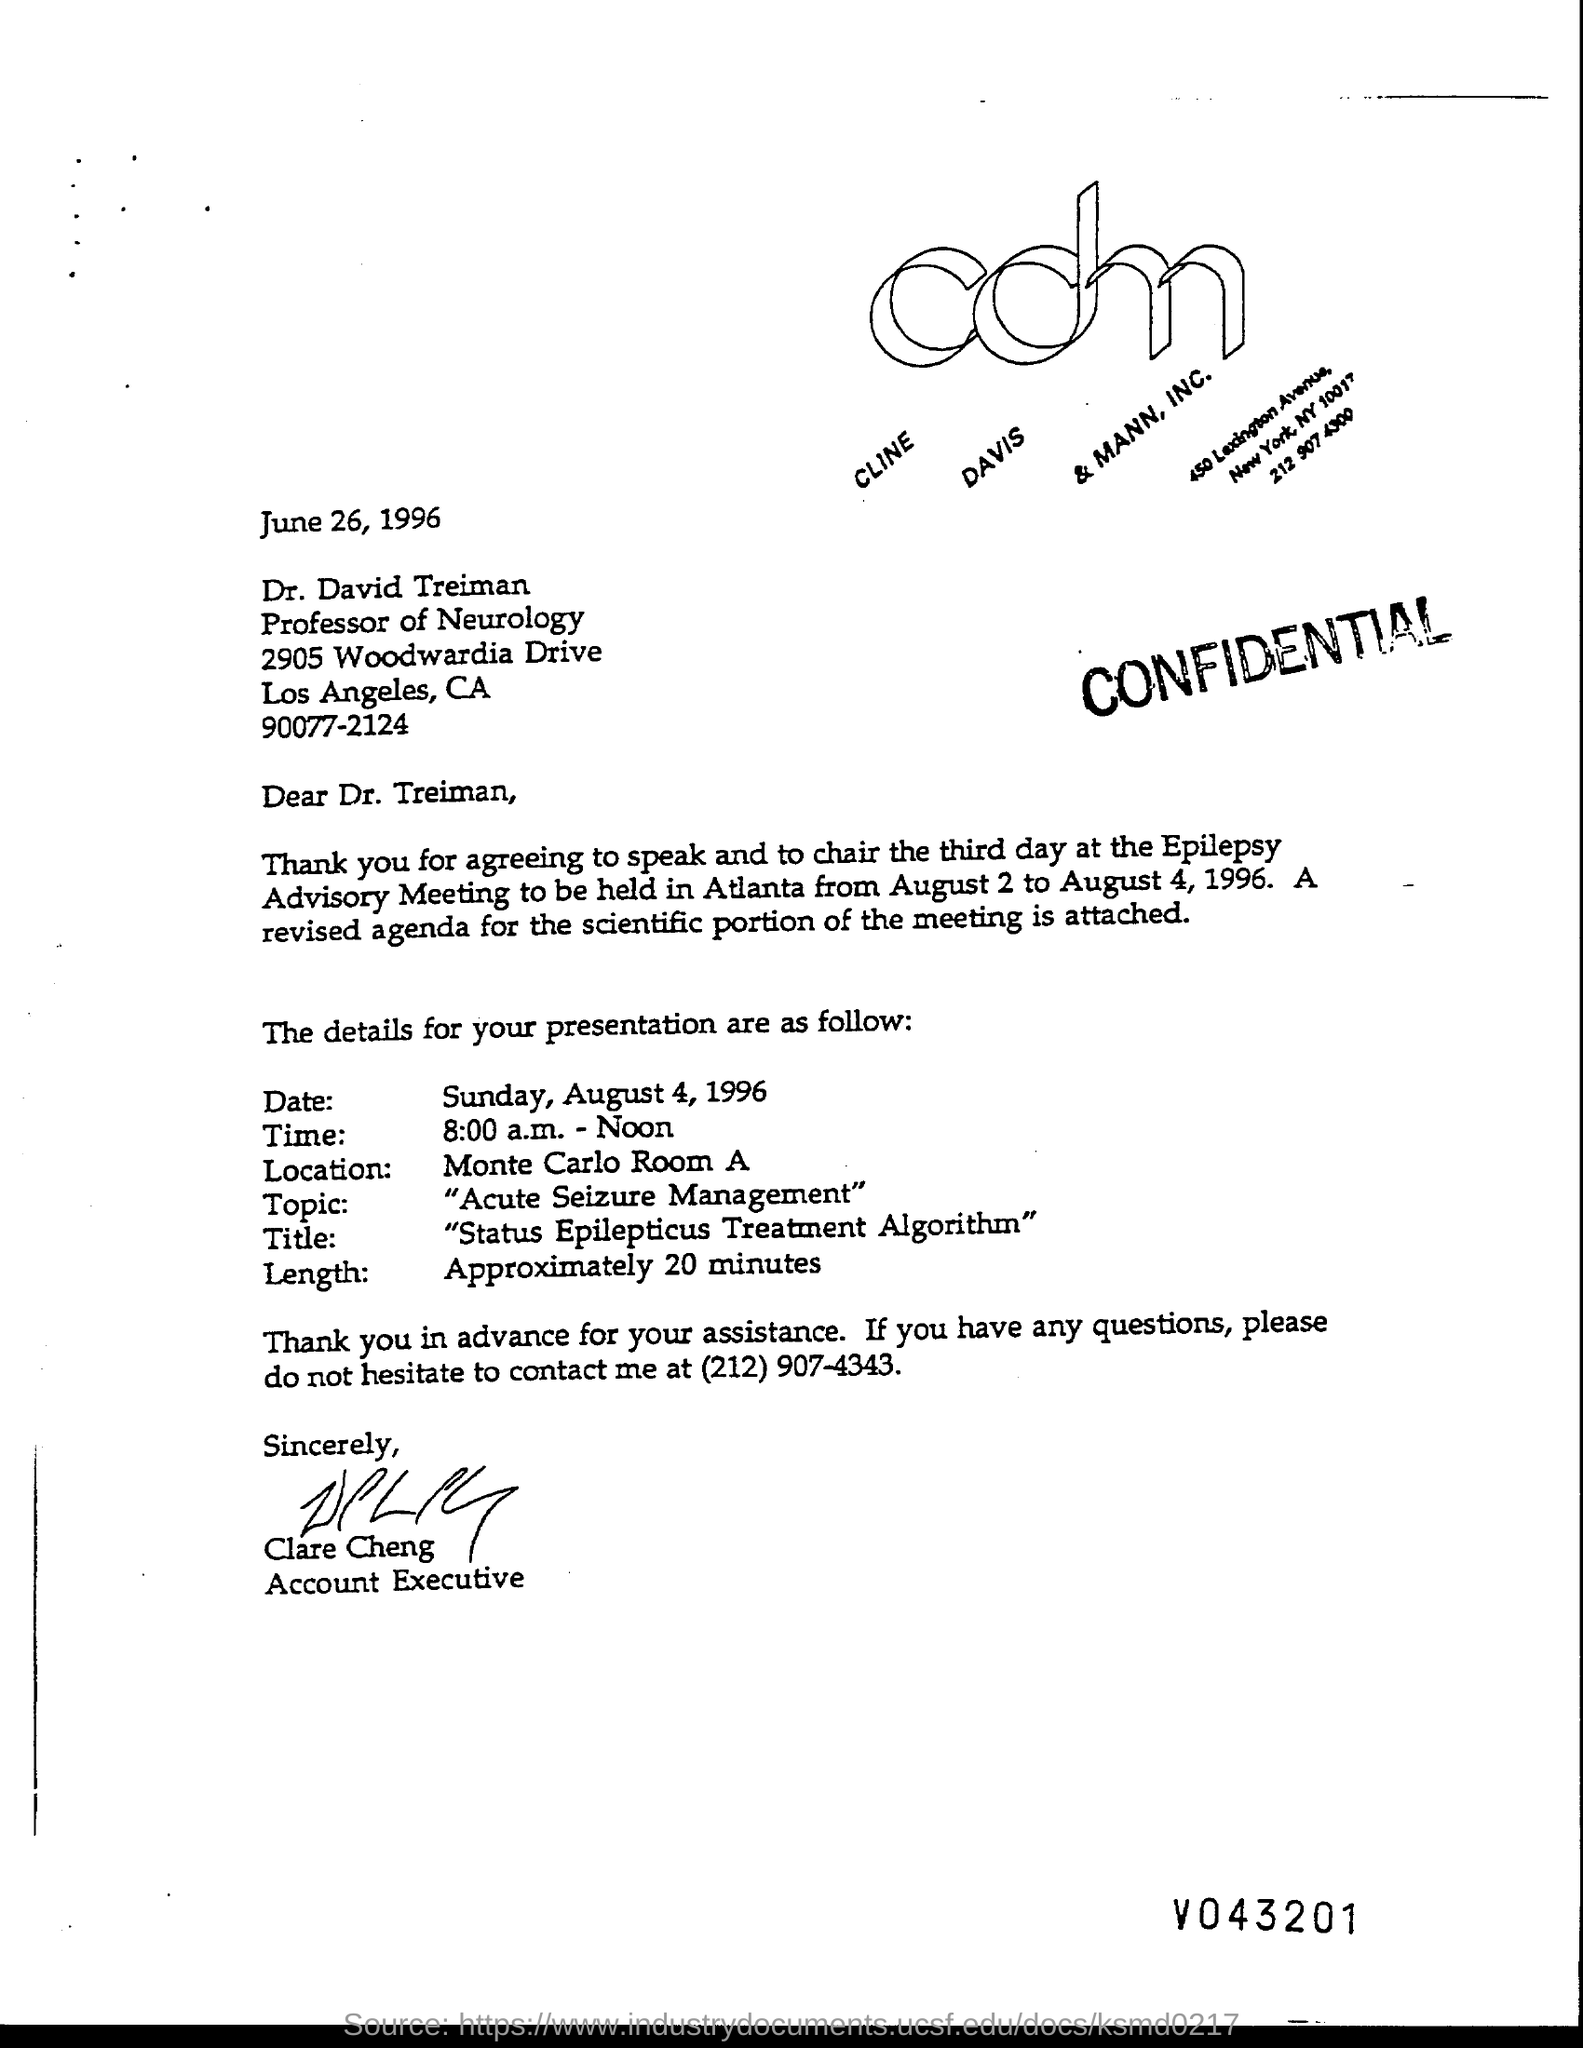List a handful of essential elements in this visual. Clare Cheng is the accountant executive. The length of the presentation is approximately 20 minutes. The topic of the presentation is acute seizure management. The title of the presentation is "Status Epilepticus Treatment Algorithm. 